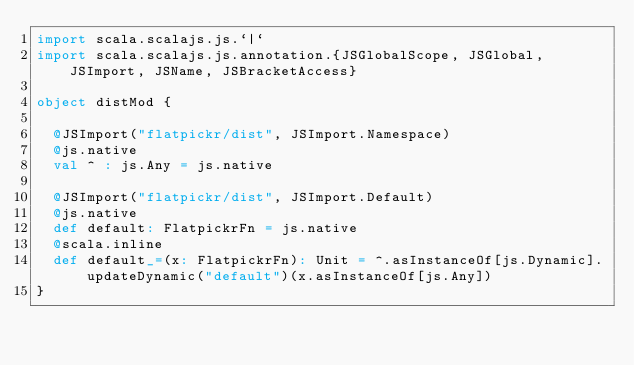<code> <loc_0><loc_0><loc_500><loc_500><_Scala_>import scala.scalajs.js.`|`
import scala.scalajs.js.annotation.{JSGlobalScope, JSGlobal, JSImport, JSName, JSBracketAccess}

object distMod {
  
  @JSImport("flatpickr/dist", JSImport.Namespace)
  @js.native
  val ^ : js.Any = js.native
  
  @JSImport("flatpickr/dist", JSImport.Default)
  @js.native
  def default: FlatpickrFn = js.native
  @scala.inline
  def default_=(x: FlatpickrFn): Unit = ^.asInstanceOf[js.Dynamic].updateDynamic("default")(x.asInstanceOf[js.Any])
}
</code> 